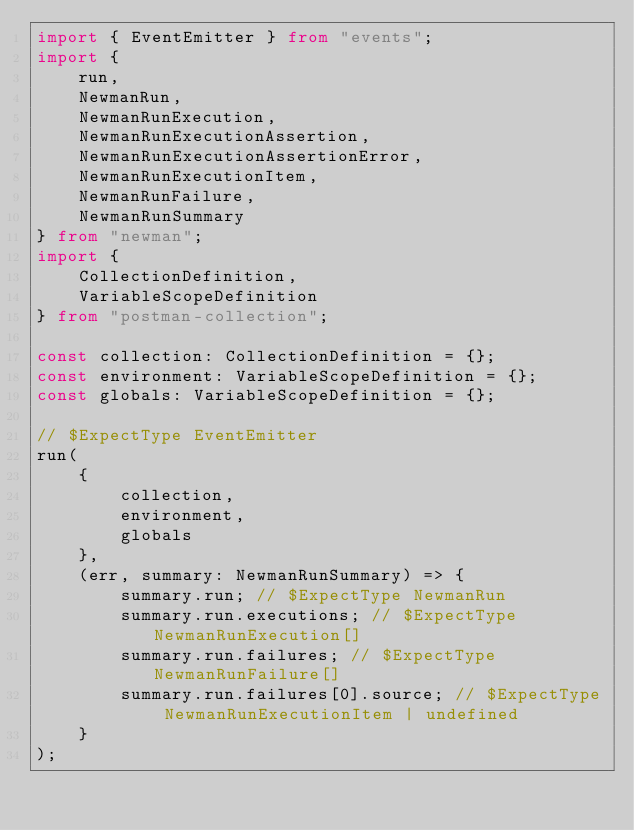<code> <loc_0><loc_0><loc_500><loc_500><_TypeScript_>import { EventEmitter } from "events";
import {
    run,
    NewmanRun,
    NewmanRunExecution,
    NewmanRunExecutionAssertion,
    NewmanRunExecutionAssertionError,
    NewmanRunExecutionItem,
    NewmanRunFailure,
    NewmanRunSummary
} from "newman";
import {
    CollectionDefinition,
    VariableScopeDefinition
} from "postman-collection";

const collection: CollectionDefinition = {};
const environment: VariableScopeDefinition = {};
const globals: VariableScopeDefinition = {};

// $ExpectType EventEmitter
run(
    {
        collection,
        environment,
        globals
    },
    (err, summary: NewmanRunSummary) => {
        summary.run; // $ExpectType NewmanRun
        summary.run.executions; // $ExpectType NewmanRunExecution[]
        summary.run.failures; // $ExpectType NewmanRunFailure[]
        summary.run.failures[0].source; // $ExpectType NewmanRunExecutionItem | undefined
    }
);
</code> 